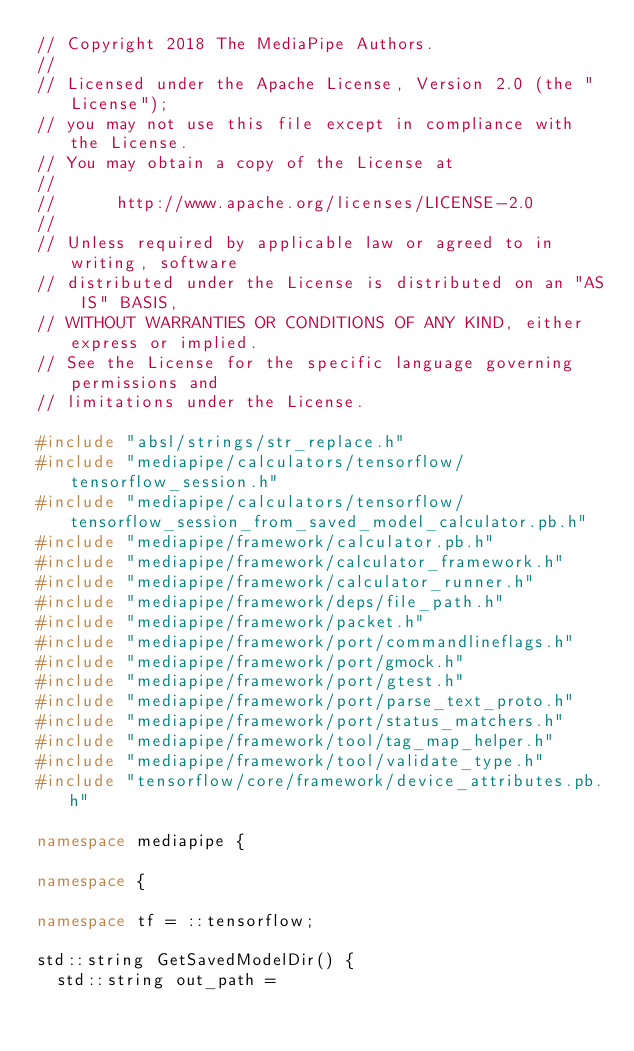<code> <loc_0><loc_0><loc_500><loc_500><_C++_>// Copyright 2018 The MediaPipe Authors.
//
// Licensed under the Apache License, Version 2.0 (the "License");
// you may not use this file except in compliance with the License.
// You may obtain a copy of the License at
//
//      http://www.apache.org/licenses/LICENSE-2.0
//
// Unless required by applicable law or agreed to in writing, software
// distributed under the License is distributed on an "AS IS" BASIS,
// WITHOUT WARRANTIES OR CONDITIONS OF ANY KIND, either express or implied.
// See the License for the specific language governing permissions and
// limitations under the License.

#include "absl/strings/str_replace.h"
#include "mediapipe/calculators/tensorflow/tensorflow_session.h"
#include "mediapipe/calculators/tensorflow/tensorflow_session_from_saved_model_calculator.pb.h"
#include "mediapipe/framework/calculator.pb.h"
#include "mediapipe/framework/calculator_framework.h"
#include "mediapipe/framework/calculator_runner.h"
#include "mediapipe/framework/deps/file_path.h"
#include "mediapipe/framework/packet.h"
#include "mediapipe/framework/port/commandlineflags.h"
#include "mediapipe/framework/port/gmock.h"
#include "mediapipe/framework/port/gtest.h"
#include "mediapipe/framework/port/parse_text_proto.h"
#include "mediapipe/framework/port/status_matchers.h"
#include "mediapipe/framework/tool/tag_map_helper.h"
#include "mediapipe/framework/tool/validate_type.h"
#include "tensorflow/core/framework/device_attributes.pb.h"

namespace mediapipe {

namespace {

namespace tf = ::tensorflow;

std::string GetSavedModelDir() {
  std::string out_path =</code> 